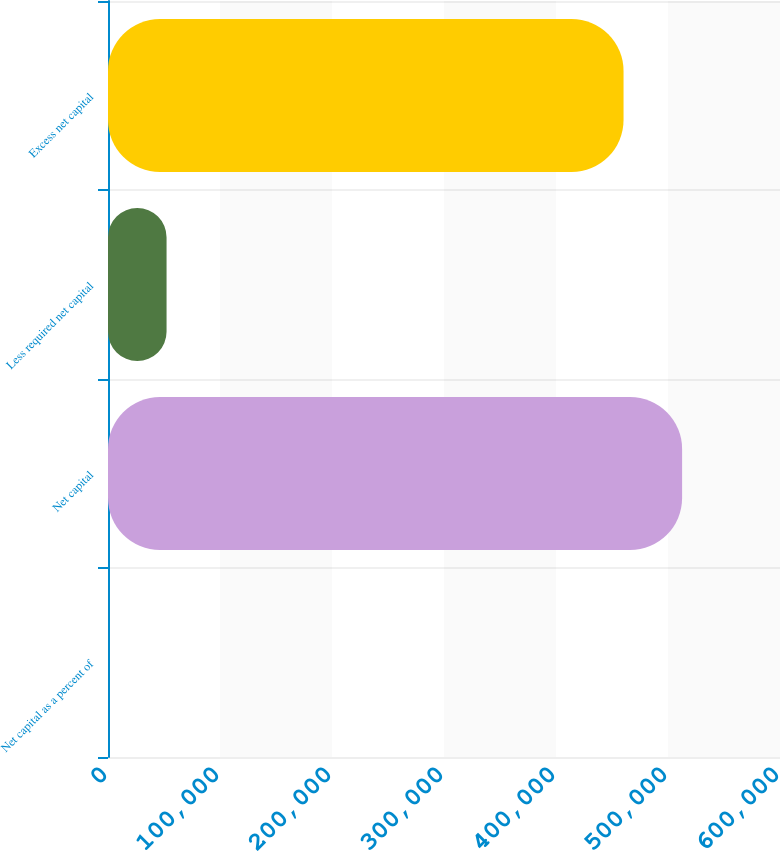<chart> <loc_0><loc_0><loc_500><loc_500><bar_chart><fcel>Net capital as a percent of<fcel>Net capital<fcel>Less required net capital<fcel>Excess net capital<nl><fcel>19.61<fcel>512594<fcel>52287<fcel>460307<nl></chart> 